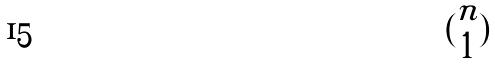Convert formula to latex. <formula><loc_0><loc_0><loc_500><loc_500>( \begin{matrix} n \\ 1 \end{matrix} )</formula> 